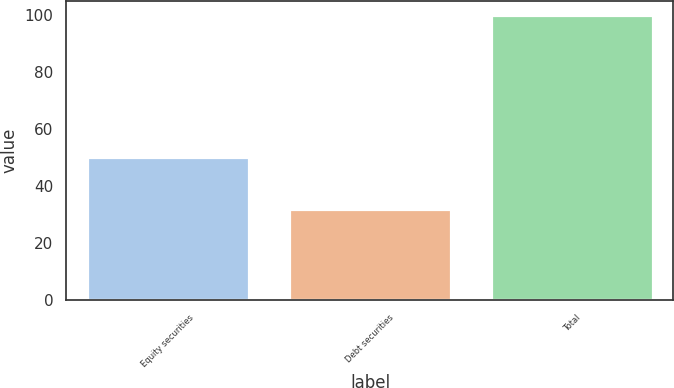Convert chart. <chart><loc_0><loc_0><loc_500><loc_500><bar_chart><fcel>Equity securities<fcel>Debt securities<fcel>Total<nl><fcel>50<fcel>32<fcel>100<nl></chart> 